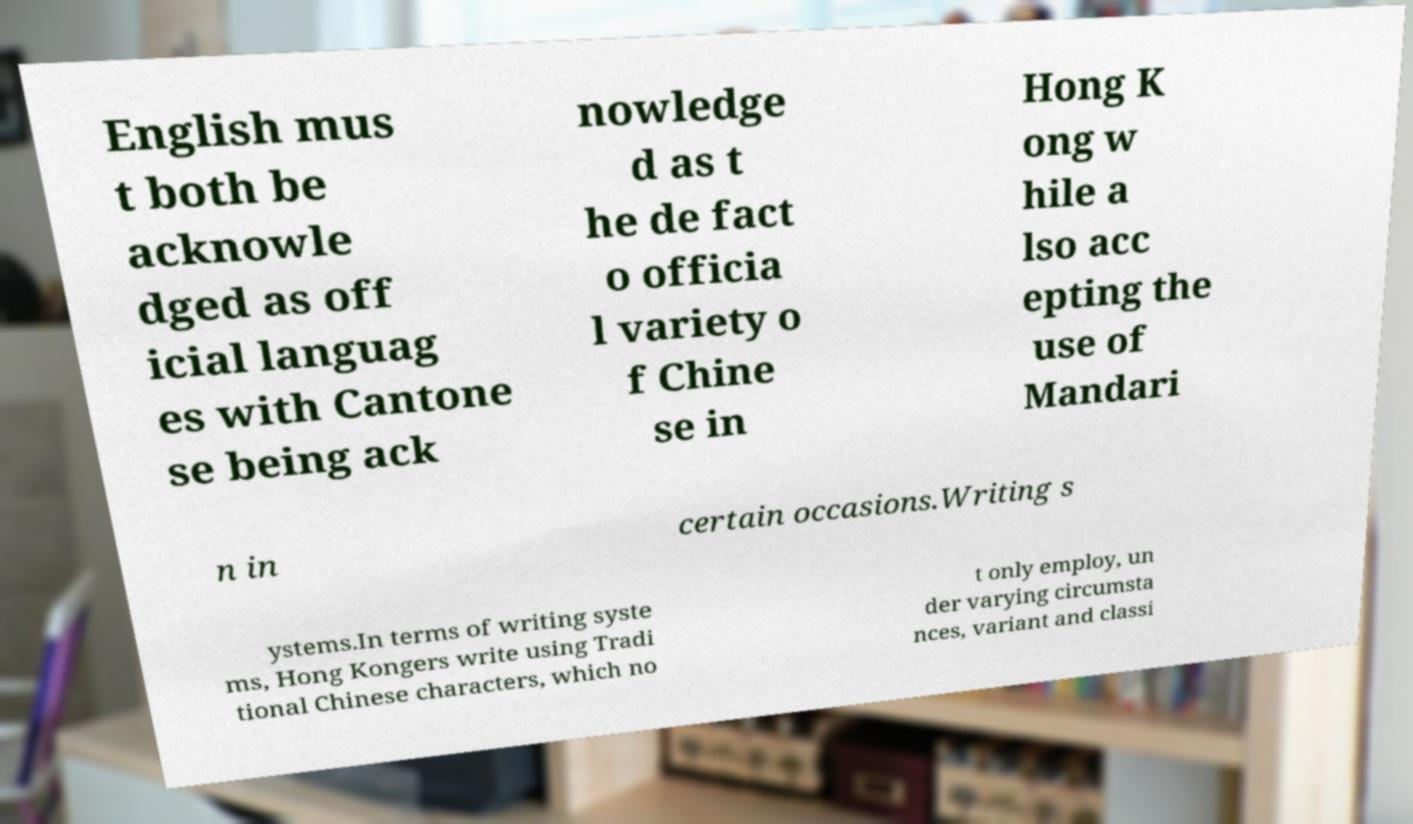Could you assist in decoding the text presented in this image and type it out clearly? English mus t both be acknowle dged as off icial languag es with Cantone se being ack nowledge d as t he de fact o officia l variety o f Chine se in Hong K ong w hile a lso acc epting the use of Mandari n in certain occasions.Writing s ystems.In terms of writing syste ms, Hong Kongers write using Tradi tional Chinese characters, which no t only employ, un der varying circumsta nces, variant and classi 